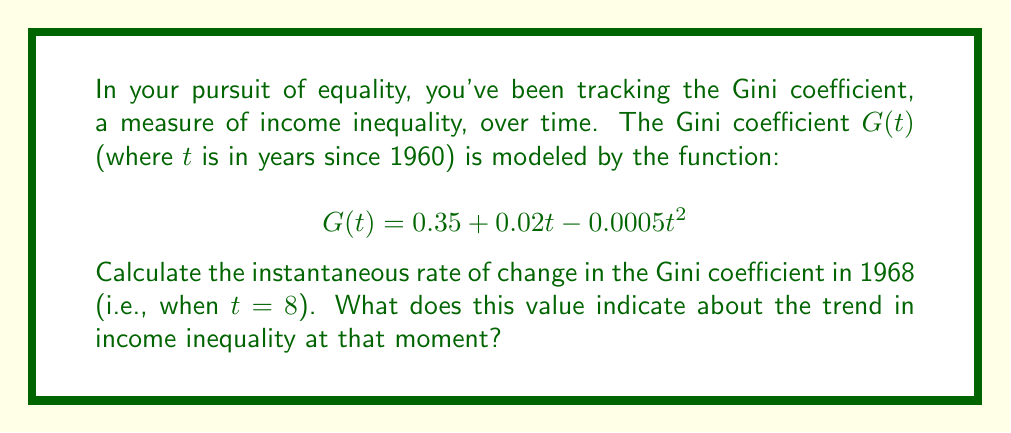Help me with this question. To find the instantaneous rate of change, we need to calculate the derivative of $G(t)$ and evaluate it at $t = 8$.

Step 1: Find the derivative of $G(t)$
$$G'(t) = \frac{d}{dt}(0.35 + 0.02t - 0.0005t^2)$$
$$G'(t) = 0 + 0.02 - 0.001t$$
$$G'(t) = 0.02 - 0.001t$$

Step 2: Evaluate $G'(t)$ at $t = 8$
$$G'(8) = 0.02 - 0.001(8)$$
$$G'(8) = 0.02 - 0.008$$
$$G'(8) = 0.012$$

Step 3: Interpret the result
The instantaneous rate of change in 1968 is 0.012, or 1.2% per year. This positive value indicates that the Gini coefficient was increasing at that moment, meaning income inequality was growing.
Answer: 0.012 (increasing inequality) 